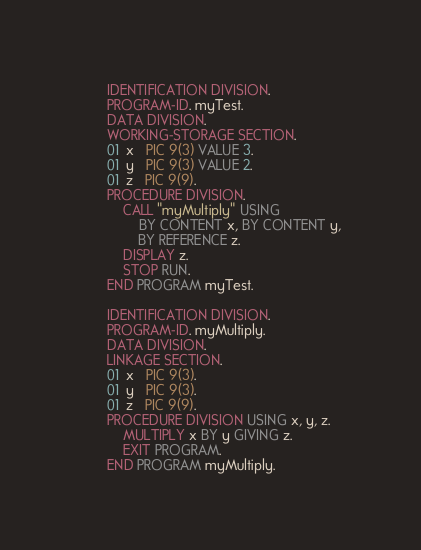Convert code to text. <code><loc_0><loc_0><loc_500><loc_500><_COBOL_>       IDENTIFICATION DIVISION.
       PROGRAM-ID. myTest.
       DATA DIVISION.
       WORKING-STORAGE SECTION.
       01  x   PIC 9(3) VALUE 3.
       01  y   PIC 9(3) VALUE 2.
       01  z   PIC 9(9).
       PROCEDURE DIVISION.
           CALL "myMultiply" USING
               BY CONTENT x, BY CONTENT y,
               BY REFERENCE z.
           DISPLAY z.
           STOP RUN.
       END PROGRAM myTest.

       IDENTIFICATION DIVISION.
       PROGRAM-ID. myMultiply.
       DATA DIVISION.
       LINKAGE SECTION.
       01  x   PIC 9(3).
       01  y   PIC 9(3).
       01  z   PIC 9(9).
       PROCEDURE DIVISION USING x, y, z.
           MULTIPLY x BY y GIVING z.
           EXIT PROGRAM.
       END PROGRAM myMultiply.
</code> 